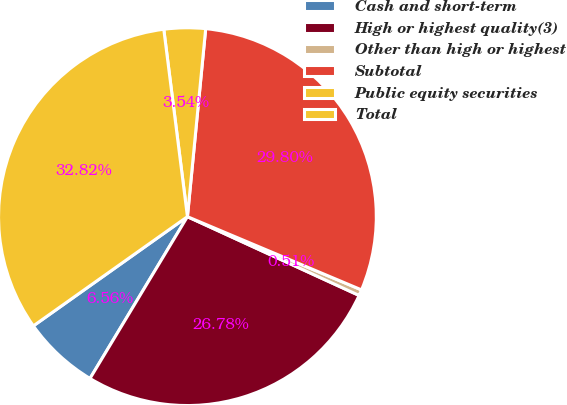<chart> <loc_0><loc_0><loc_500><loc_500><pie_chart><fcel>Cash and short-term<fcel>High or highest quality(3)<fcel>Other than high or highest<fcel>Subtotal<fcel>Public equity securities<fcel>Total<nl><fcel>6.56%<fcel>26.78%<fcel>0.51%<fcel>29.8%<fcel>3.54%<fcel>32.82%<nl></chart> 